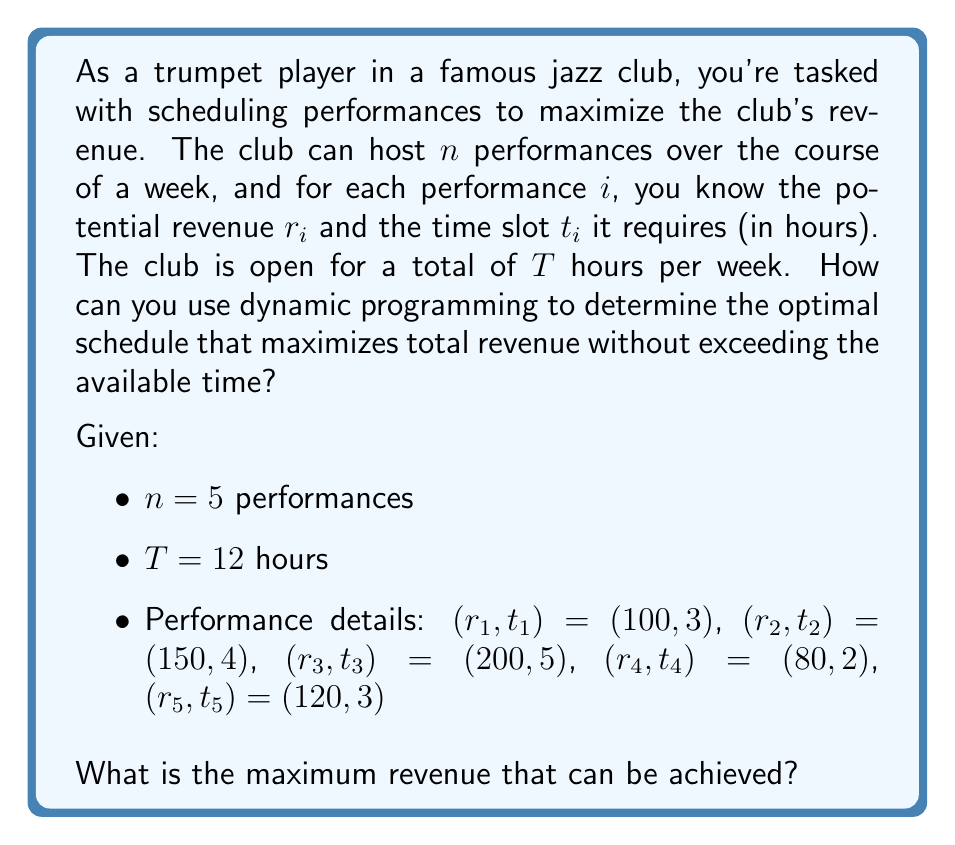Can you solve this math problem? To solve this problem using dynamic programming, we can follow these steps:

1) Define the subproblem:
   Let $DP[i][j]$ be the maximum revenue that can be achieved using the first $i$ performances and exactly $j$ hours.

2) Establish the recurrence relation:
   For each performance $i$ and time $j$, we have two choices:
   a) Don't include performance $i$: $DP[i][j] = DP[i-1][j]$
   b) Include performance $i$ (if possible): $DP[i][j] = r_i + DP[i-1][j-t_i]$
   
   The recurrence relation is:
   $$DP[i][j] = \max(DP[i-1][j], r_i + DP[i-1][j-t_i])$$
   if $j \geq t_i$, otherwise $DP[i][j] = DP[i-1][j]$

3) Initialize the base cases:
   $DP[0][j] = 0$ for all $j$
   $DP[i][0] = 0$ for all $i$

4) Fill the DP table:
   We'll create a table with $n+1$ rows and $T+1$ columns.

   Here's the filled DP table:

   $$
   \begin{array}{c|cccccccccccccc}
   i\backslash j & 0 & 1 & 2 & 3 & 4 & 5 & 6 & 7 & 8 & 9 & 10 & 11 & 12 \\
   \hline
   0 & 0 & 0 & 0 & 0 & 0 & 0 & 0 & 0 & 0 & 0 & 0 & 0 & 0 \\
   1 & 0 & 0 & 0 & 100 & 100 & 100 & 100 & 100 & 100 & 100 & 100 & 100 & 100 \\
   2 & 0 & 0 & 0 & 100 & 150 & 150 & 150 & 250 & 250 & 250 & 250 & 250 & 250 \\
   3 & 0 & 0 & 0 & 100 & 150 & 200 & 200 & 250 & 250 & 300 & 350 & 350 & 350 \\
   4 & 0 & 0 & 80 & 100 & 150 & 200 & 200 & 250 & 280 & 300 & 350 & 350 & 430 \\
   5 & 0 & 0 & 80 & 120 & 150 & 200 & 220 & 250 & 280 & 320 & 350 & 370 & 430 \\
   \end{array}
   $$

5) The optimal solution is in $DP[n][T]$, which is $DP[5][12] = 430$.

To reconstruct the optimal schedule, we can backtrack through the DP table:
- Start at $DP[5][12] = 430$
- This came from including performance 5: $430 = 120 + DP[4][9]$
- $DP[4][9] = 300$ came from including performance 3: $300 = 200 + DP[3][4]$
- $DP[3][4] = 150$ came from including performance 2

So, the optimal schedule includes performances 2, 3, and 5.
Answer: The maximum revenue that can be achieved is $430, by scheduling performances 2 ($150), 3 ($200), and 5 ($120). 